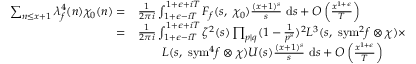<formula> <loc_0><loc_0><loc_500><loc_500>\begin{array} { r l } { \sum _ { n \leq x + 1 } \lambda _ { f } ^ { 4 } ( n ) \chi _ { 0 } ( n ) = } & { \frac { 1 } { 2 \pi i } \int _ { 1 + \epsilon - i T } ^ { 1 + \epsilon + i T } F _ { f } ( s , \ \chi _ { 0 } ) \frac { ( x + 1 ) ^ { s } } { s } \ d s + O \left ( \frac { x ^ { 1 + \epsilon } } { T } \right ) } \\ { = } & { \frac { 1 } { 2 \pi i } \int _ { 1 + \epsilon - i T } ^ { 1 + \epsilon + i T } \zeta ^ { 2 } ( s ) \prod _ { p | q } ( 1 - \frac { 1 } { p ^ { s } } ) ^ { 2 } L ^ { 3 } ( s , \ { s y m } ^ { 2 } f \otimes \chi ) \times } \\ & { \quad L ( s , \ { s y m } ^ { 4 } f \otimes \chi ) U ( s ) \frac { ( x + 1 ) ^ { s } } { s } \ d s + O \left ( \frac { x ^ { 1 + \epsilon } } { T } \right ) } \end{array}</formula> 